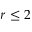Convert formula to latex. <formula><loc_0><loc_0><loc_500><loc_500>r \leq 2</formula> 